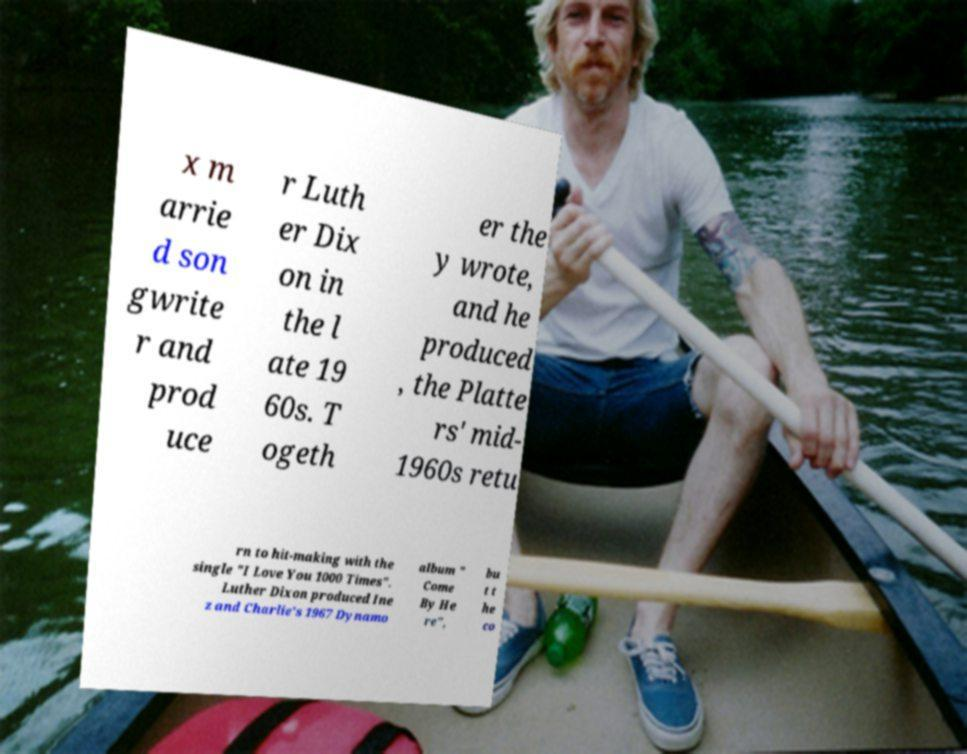What messages or text are displayed in this image? I need them in a readable, typed format. x m arrie d son gwrite r and prod uce r Luth er Dix on in the l ate 19 60s. T ogeth er the y wrote, and he produced , the Platte rs' mid- 1960s retu rn to hit-making with the single "I Love You 1000 Times". Luther Dixon produced Ine z and Charlie's 1967 Dynamo album " Come By He re", bu t t he co 